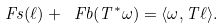Convert formula to latex. <formula><loc_0><loc_0><loc_500><loc_500>\ F s ( \ell ) + \ F b ( T ^ { * } \omega ) = \langle \omega , T \ell \rangle .</formula> 